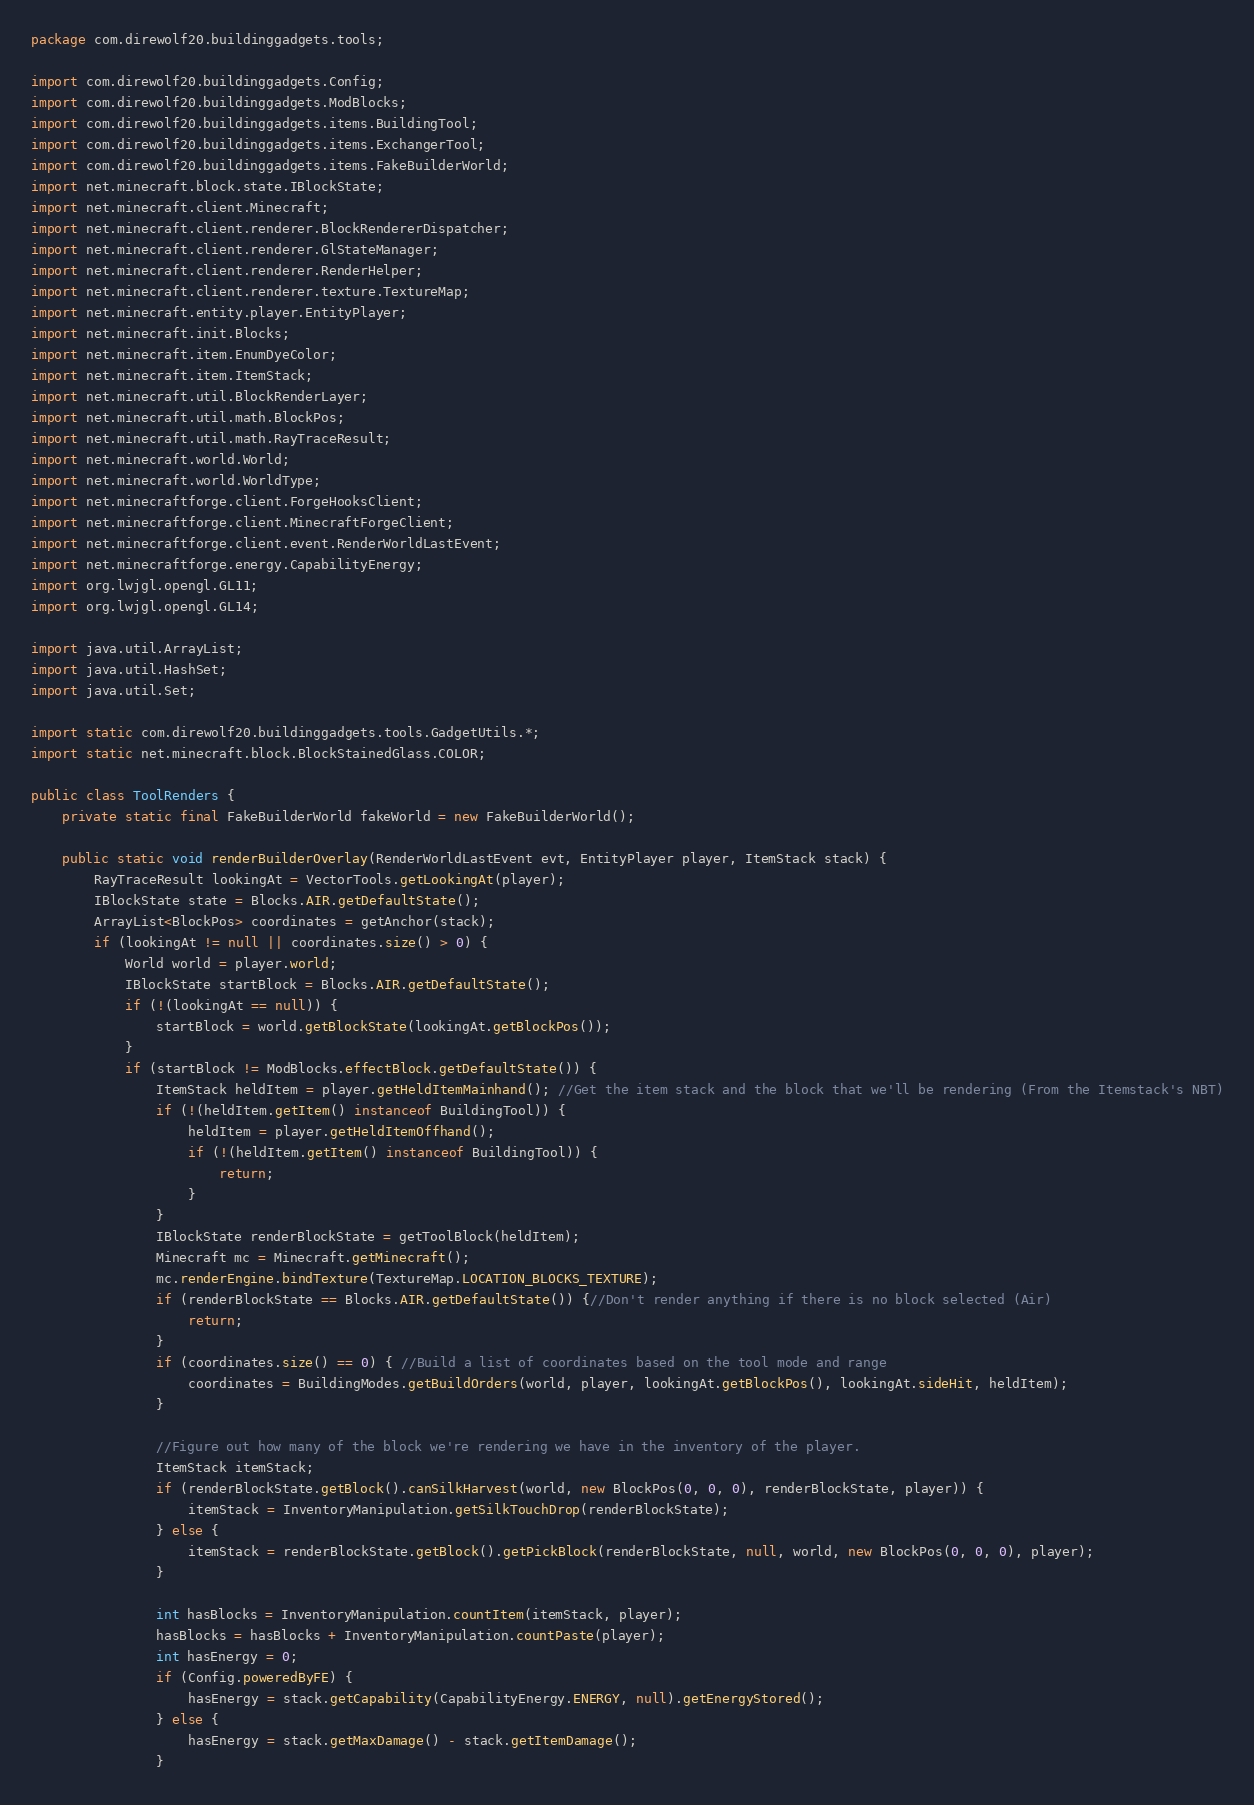Convert code to text. <code><loc_0><loc_0><loc_500><loc_500><_Java_>package com.direwolf20.buildinggadgets.tools;

import com.direwolf20.buildinggadgets.Config;
import com.direwolf20.buildinggadgets.ModBlocks;
import com.direwolf20.buildinggadgets.items.BuildingTool;
import com.direwolf20.buildinggadgets.items.ExchangerTool;
import com.direwolf20.buildinggadgets.items.FakeBuilderWorld;
import net.minecraft.block.state.IBlockState;
import net.minecraft.client.Minecraft;
import net.minecraft.client.renderer.BlockRendererDispatcher;
import net.minecraft.client.renderer.GlStateManager;
import net.minecraft.client.renderer.RenderHelper;
import net.minecraft.client.renderer.texture.TextureMap;
import net.minecraft.entity.player.EntityPlayer;
import net.minecraft.init.Blocks;
import net.minecraft.item.EnumDyeColor;
import net.minecraft.item.ItemStack;
import net.minecraft.util.BlockRenderLayer;
import net.minecraft.util.math.BlockPos;
import net.minecraft.util.math.RayTraceResult;
import net.minecraft.world.World;
import net.minecraft.world.WorldType;
import net.minecraftforge.client.ForgeHooksClient;
import net.minecraftforge.client.MinecraftForgeClient;
import net.minecraftforge.client.event.RenderWorldLastEvent;
import net.minecraftforge.energy.CapabilityEnergy;
import org.lwjgl.opengl.GL11;
import org.lwjgl.opengl.GL14;

import java.util.ArrayList;
import java.util.HashSet;
import java.util.Set;

import static com.direwolf20.buildinggadgets.tools.GadgetUtils.*;
import static net.minecraft.block.BlockStainedGlass.COLOR;

public class ToolRenders {
    private static final FakeBuilderWorld fakeWorld = new FakeBuilderWorld();

    public static void renderBuilderOverlay(RenderWorldLastEvent evt, EntityPlayer player, ItemStack stack) {
        RayTraceResult lookingAt = VectorTools.getLookingAt(player);
        IBlockState state = Blocks.AIR.getDefaultState();
        ArrayList<BlockPos> coordinates = getAnchor(stack);
        if (lookingAt != null || coordinates.size() > 0) {
            World world = player.world;
            IBlockState startBlock = Blocks.AIR.getDefaultState();
            if (!(lookingAt == null)) {
                startBlock = world.getBlockState(lookingAt.getBlockPos());
            }
            if (startBlock != ModBlocks.effectBlock.getDefaultState()) {
                ItemStack heldItem = player.getHeldItemMainhand(); //Get the item stack and the block that we'll be rendering (From the Itemstack's NBT)
                if (!(heldItem.getItem() instanceof BuildingTool)) {
                    heldItem = player.getHeldItemOffhand();
                    if (!(heldItem.getItem() instanceof BuildingTool)) {
                        return;
                    }
                }
                IBlockState renderBlockState = getToolBlock(heldItem);
                Minecraft mc = Minecraft.getMinecraft();
                mc.renderEngine.bindTexture(TextureMap.LOCATION_BLOCKS_TEXTURE);
                if (renderBlockState == Blocks.AIR.getDefaultState()) {//Don't render anything if there is no block selected (Air)
                    return;
                }
                if (coordinates.size() == 0) { //Build a list of coordinates based on the tool mode and range
                    coordinates = BuildingModes.getBuildOrders(world, player, lookingAt.getBlockPos(), lookingAt.sideHit, heldItem);
                }

                //Figure out how many of the block we're rendering we have in the inventory of the player.
                ItemStack itemStack;
                if (renderBlockState.getBlock().canSilkHarvest(world, new BlockPos(0, 0, 0), renderBlockState, player)) {
                    itemStack = InventoryManipulation.getSilkTouchDrop(renderBlockState);
                } else {
                    itemStack = renderBlockState.getBlock().getPickBlock(renderBlockState, null, world, new BlockPos(0, 0, 0), player);
                }

                int hasBlocks = InventoryManipulation.countItem(itemStack, player);
                hasBlocks = hasBlocks + InventoryManipulation.countPaste(player);
                int hasEnergy = 0;
                if (Config.poweredByFE) {
                    hasEnergy = stack.getCapability(CapabilityEnergy.ENERGY, null).getEnergyStored();
                } else {
                    hasEnergy = stack.getMaxDamage() - stack.getItemDamage();
                }</code> 